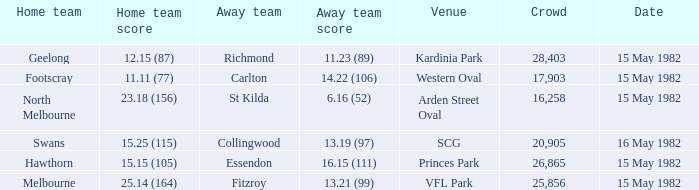What did the away team score when playing Footscray? 14.22 (106). 